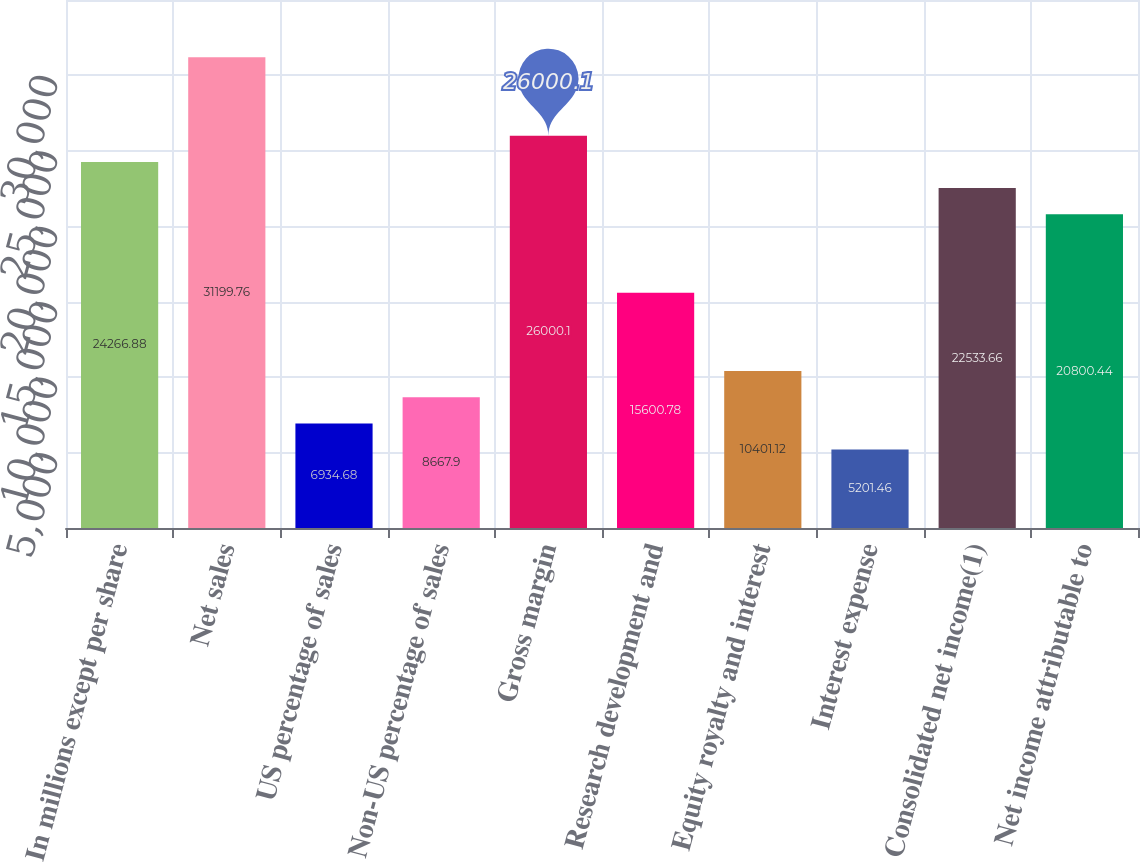Convert chart to OTSL. <chart><loc_0><loc_0><loc_500><loc_500><bar_chart><fcel>In millions except per share<fcel>Net sales<fcel>US percentage of sales<fcel>Non-US percentage of sales<fcel>Gross margin<fcel>Research development and<fcel>Equity royalty and interest<fcel>Interest expense<fcel>Consolidated net income(1)<fcel>Net income attributable to<nl><fcel>24266.9<fcel>31199.8<fcel>6934.68<fcel>8667.9<fcel>26000.1<fcel>15600.8<fcel>10401.1<fcel>5201.46<fcel>22533.7<fcel>20800.4<nl></chart> 